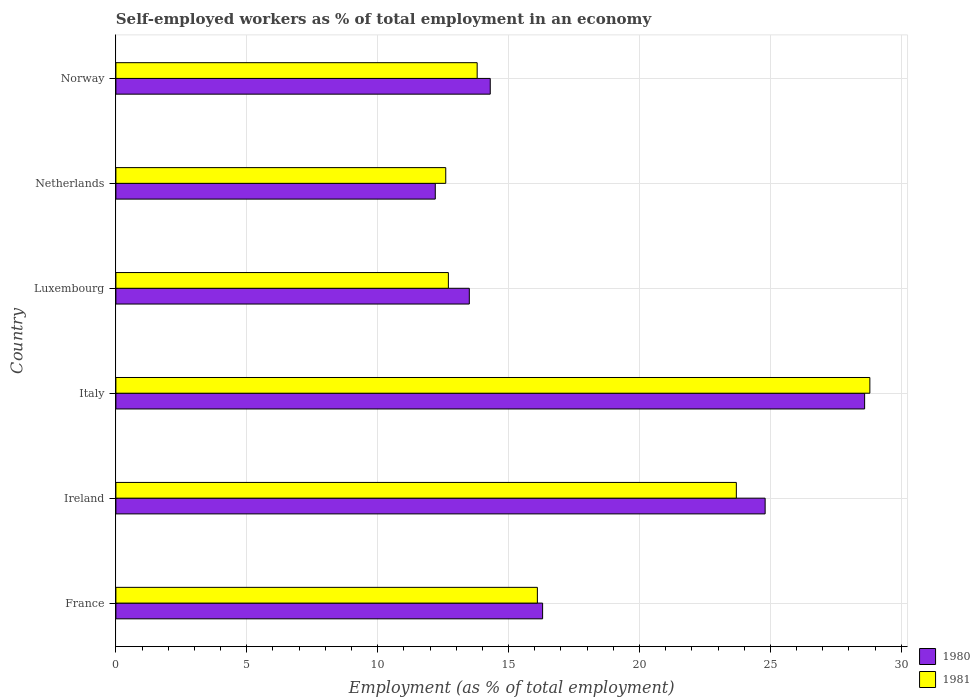How many groups of bars are there?
Your answer should be very brief. 6. Are the number of bars on each tick of the Y-axis equal?
Make the answer very short. Yes. How many bars are there on the 6th tick from the top?
Your answer should be very brief. 2. What is the label of the 5th group of bars from the top?
Your answer should be very brief. Ireland. What is the percentage of self-employed workers in 1981 in Netherlands?
Keep it short and to the point. 12.6. Across all countries, what is the maximum percentage of self-employed workers in 1980?
Your response must be concise. 28.6. Across all countries, what is the minimum percentage of self-employed workers in 1980?
Your answer should be very brief. 12.2. What is the total percentage of self-employed workers in 1981 in the graph?
Offer a terse response. 107.7. What is the difference between the percentage of self-employed workers in 1981 in Ireland and that in Italy?
Provide a succinct answer. -5.1. What is the difference between the percentage of self-employed workers in 1980 in Italy and the percentage of self-employed workers in 1981 in Norway?
Offer a terse response. 14.8. What is the average percentage of self-employed workers in 1981 per country?
Your answer should be very brief. 17.95. What is the difference between the percentage of self-employed workers in 1981 and percentage of self-employed workers in 1980 in Luxembourg?
Provide a succinct answer. -0.8. In how many countries, is the percentage of self-employed workers in 1981 greater than 24 %?
Provide a succinct answer. 1. What is the ratio of the percentage of self-employed workers in 1981 in Italy to that in Luxembourg?
Provide a short and direct response. 2.27. Is the percentage of self-employed workers in 1980 in Italy less than that in Netherlands?
Provide a succinct answer. No. What is the difference between the highest and the second highest percentage of self-employed workers in 1981?
Make the answer very short. 5.1. What is the difference between the highest and the lowest percentage of self-employed workers in 1980?
Provide a short and direct response. 16.4. In how many countries, is the percentage of self-employed workers in 1981 greater than the average percentage of self-employed workers in 1981 taken over all countries?
Your answer should be compact. 2. Is the sum of the percentage of self-employed workers in 1981 in Ireland and Italy greater than the maximum percentage of self-employed workers in 1980 across all countries?
Your answer should be very brief. Yes. What does the 2nd bar from the top in Luxembourg represents?
Give a very brief answer. 1980. What does the 1st bar from the bottom in Luxembourg represents?
Provide a succinct answer. 1980. How many bars are there?
Offer a terse response. 12. Does the graph contain any zero values?
Your answer should be compact. No. Does the graph contain grids?
Your answer should be very brief. Yes. Where does the legend appear in the graph?
Provide a short and direct response. Bottom right. What is the title of the graph?
Keep it short and to the point. Self-employed workers as % of total employment in an economy. What is the label or title of the X-axis?
Your answer should be compact. Employment (as % of total employment). What is the label or title of the Y-axis?
Offer a very short reply. Country. What is the Employment (as % of total employment) of 1980 in France?
Make the answer very short. 16.3. What is the Employment (as % of total employment) in 1981 in France?
Offer a terse response. 16.1. What is the Employment (as % of total employment) in 1980 in Ireland?
Your answer should be very brief. 24.8. What is the Employment (as % of total employment) of 1981 in Ireland?
Offer a terse response. 23.7. What is the Employment (as % of total employment) in 1980 in Italy?
Ensure brevity in your answer.  28.6. What is the Employment (as % of total employment) in 1981 in Italy?
Your answer should be compact. 28.8. What is the Employment (as % of total employment) of 1981 in Luxembourg?
Make the answer very short. 12.7. What is the Employment (as % of total employment) of 1980 in Netherlands?
Keep it short and to the point. 12.2. What is the Employment (as % of total employment) of 1981 in Netherlands?
Offer a very short reply. 12.6. What is the Employment (as % of total employment) in 1980 in Norway?
Keep it short and to the point. 14.3. What is the Employment (as % of total employment) in 1981 in Norway?
Provide a short and direct response. 13.8. Across all countries, what is the maximum Employment (as % of total employment) in 1980?
Your answer should be very brief. 28.6. Across all countries, what is the maximum Employment (as % of total employment) of 1981?
Offer a terse response. 28.8. Across all countries, what is the minimum Employment (as % of total employment) of 1980?
Give a very brief answer. 12.2. Across all countries, what is the minimum Employment (as % of total employment) of 1981?
Provide a succinct answer. 12.6. What is the total Employment (as % of total employment) in 1980 in the graph?
Keep it short and to the point. 109.7. What is the total Employment (as % of total employment) in 1981 in the graph?
Make the answer very short. 107.7. What is the difference between the Employment (as % of total employment) of 1980 in France and that in Italy?
Make the answer very short. -12.3. What is the difference between the Employment (as % of total employment) of 1981 in France and that in Italy?
Provide a succinct answer. -12.7. What is the difference between the Employment (as % of total employment) in 1981 in France and that in Luxembourg?
Your answer should be compact. 3.4. What is the difference between the Employment (as % of total employment) of 1981 in France and that in Netherlands?
Your response must be concise. 3.5. What is the difference between the Employment (as % of total employment) in 1980 in France and that in Norway?
Make the answer very short. 2. What is the difference between the Employment (as % of total employment) of 1980 in Ireland and that in Italy?
Your answer should be compact. -3.8. What is the difference between the Employment (as % of total employment) of 1981 in Ireland and that in Luxembourg?
Provide a succinct answer. 11. What is the difference between the Employment (as % of total employment) in 1981 in Ireland and that in Netherlands?
Give a very brief answer. 11.1. What is the difference between the Employment (as % of total employment) in 1981 in Ireland and that in Norway?
Offer a terse response. 9.9. What is the difference between the Employment (as % of total employment) of 1980 in Italy and that in Luxembourg?
Make the answer very short. 15.1. What is the difference between the Employment (as % of total employment) in 1980 in Italy and that in Netherlands?
Offer a very short reply. 16.4. What is the difference between the Employment (as % of total employment) of 1981 in Italy and that in Norway?
Your answer should be compact. 15. What is the difference between the Employment (as % of total employment) in 1980 in Luxembourg and that in Netherlands?
Your response must be concise. 1.3. What is the difference between the Employment (as % of total employment) in 1980 in Luxembourg and that in Norway?
Your answer should be compact. -0.8. What is the difference between the Employment (as % of total employment) of 1981 in Luxembourg and that in Norway?
Ensure brevity in your answer.  -1.1. What is the difference between the Employment (as % of total employment) in 1980 in Netherlands and that in Norway?
Offer a terse response. -2.1. What is the difference between the Employment (as % of total employment) in 1981 in Netherlands and that in Norway?
Your response must be concise. -1.2. What is the difference between the Employment (as % of total employment) in 1980 in France and the Employment (as % of total employment) in 1981 in Ireland?
Provide a short and direct response. -7.4. What is the difference between the Employment (as % of total employment) in 1980 in France and the Employment (as % of total employment) in 1981 in Netherlands?
Provide a succinct answer. 3.7. What is the difference between the Employment (as % of total employment) of 1980 in Ireland and the Employment (as % of total employment) of 1981 in Norway?
Provide a succinct answer. 11. What is the difference between the Employment (as % of total employment) in 1980 in Italy and the Employment (as % of total employment) in 1981 in Norway?
Offer a terse response. 14.8. What is the difference between the Employment (as % of total employment) of 1980 in Luxembourg and the Employment (as % of total employment) of 1981 in Norway?
Make the answer very short. -0.3. What is the difference between the Employment (as % of total employment) in 1980 in Netherlands and the Employment (as % of total employment) in 1981 in Norway?
Your response must be concise. -1.6. What is the average Employment (as % of total employment) of 1980 per country?
Your answer should be very brief. 18.28. What is the average Employment (as % of total employment) of 1981 per country?
Your response must be concise. 17.95. What is the difference between the Employment (as % of total employment) in 1980 and Employment (as % of total employment) in 1981 in France?
Keep it short and to the point. 0.2. What is the difference between the Employment (as % of total employment) of 1980 and Employment (as % of total employment) of 1981 in Luxembourg?
Offer a very short reply. 0.8. What is the ratio of the Employment (as % of total employment) in 1980 in France to that in Ireland?
Offer a very short reply. 0.66. What is the ratio of the Employment (as % of total employment) in 1981 in France to that in Ireland?
Offer a terse response. 0.68. What is the ratio of the Employment (as % of total employment) in 1980 in France to that in Italy?
Your answer should be compact. 0.57. What is the ratio of the Employment (as % of total employment) in 1981 in France to that in Italy?
Make the answer very short. 0.56. What is the ratio of the Employment (as % of total employment) of 1980 in France to that in Luxembourg?
Keep it short and to the point. 1.21. What is the ratio of the Employment (as % of total employment) in 1981 in France to that in Luxembourg?
Offer a terse response. 1.27. What is the ratio of the Employment (as % of total employment) in 1980 in France to that in Netherlands?
Make the answer very short. 1.34. What is the ratio of the Employment (as % of total employment) of 1981 in France to that in Netherlands?
Your answer should be very brief. 1.28. What is the ratio of the Employment (as % of total employment) in 1980 in France to that in Norway?
Your response must be concise. 1.14. What is the ratio of the Employment (as % of total employment) in 1980 in Ireland to that in Italy?
Your answer should be very brief. 0.87. What is the ratio of the Employment (as % of total employment) of 1981 in Ireland to that in Italy?
Your answer should be very brief. 0.82. What is the ratio of the Employment (as % of total employment) of 1980 in Ireland to that in Luxembourg?
Give a very brief answer. 1.84. What is the ratio of the Employment (as % of total employment) of 1981 in Ireland to that in Luxembourg?
Make the answer very short. 1.87. What is the ratio of the Employment (as % of total employment) of 1980 in Ireland to that in Netherlands?
Your response must be concise. 2.03. What is the ratio of the Employment (as % of total employment) of 1981 in Ireland to that in Netherlands?
Keep it short and to the point. 1.88. What is the ratio of the Employment (as % of total employment) of 1980 in Ireland to that in Norway?
Make the answer very short. 1.73. What is the ratio of the Employment (as % of total employment) of 1981 in Ireland to that in Norway?
Your answer should be very brief. 1.72. What is the ratio of the Employment (as % of total employment) in 1980 in Italy to that in Luxembourg?
Offer a terse response. 2.12. What is the ratio of the Employment (as % of total employment) in 1981 in Italy to that in Luxembourg?
Make the answer very short. 2.27. What is the ratio of the Employment (as % of total employment) of 1980 in Italy to that in Netherlands?
Keep it short and to the point. 2.34. What is the ratio of the Employment (as % of total employment) in 1981 in Italy to that in Netherlands?
Provide a short and direct response. 2.29. What is the ratio of the Employment (as % of total employment) in 1981 in Italy to that in Norway?
Give a very brief answer. 2.09. What is the ratio of the Employment (as % of total employment) in 1980 in Luxembourg to that in Netherlands?
Provide a short and direct response. 1.11. What is the ratio of the Employment (as % of total employment) of 1981 in Luxembourg to that in Netherlands?
Your answer should be very brief. 1.01. What is the ratio of the Employment (as % of total employment) of 1980 in Luxembourg to that in Norway?
Provide a succinct answer. 0.94. What is the ratio of the Employment (as % of total employment) of 1981 in Luxembourg to that in Norway?
Your response must be concise. 0.92. What is the ratio of the Employment (as % of total employment) of 1980 in Netherlands to that in Norway?
Your response must be concise. 0.85. What is the ratio of the Employment (as % of total employment) of 1981 in Netherlands to that in Norway?
Your answer should be very brief. 0.91. What is the difference between the highest and the second highest Employment (as % of total employment) of 1980?
Ensure brevity in your answer.  3.8. What is the difference between the highest and the second highest Employment (as % of total employment) of 1981?
Keep it short and to the point. 5.1. What is the difference between the highest and the lowest Employment (as % of total employment) in 1980?
Your answer should be compact. 16.4. 